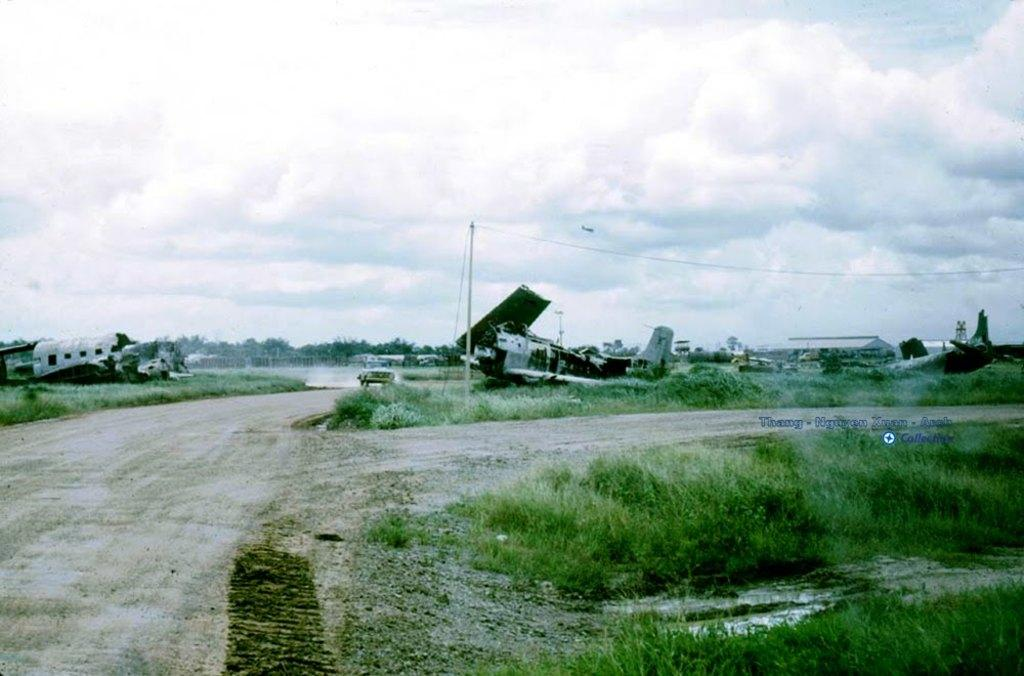What type of surface can be seen in the image? There is a road in the image. What type of vegetation is present on the ground in the image? There is grass on the ground in the image. What type of vehicles can be seen in the image? There are damaged aircrafts and other vehicles in the image. What can be seen in the background of the image? There are trees, a pole, and the sky visible in the background of the image. What type of hill can be seen in the image? There is no hill present in the image. What type of religious symbol can be seen in the image? There is no religious symbol present in the image. 